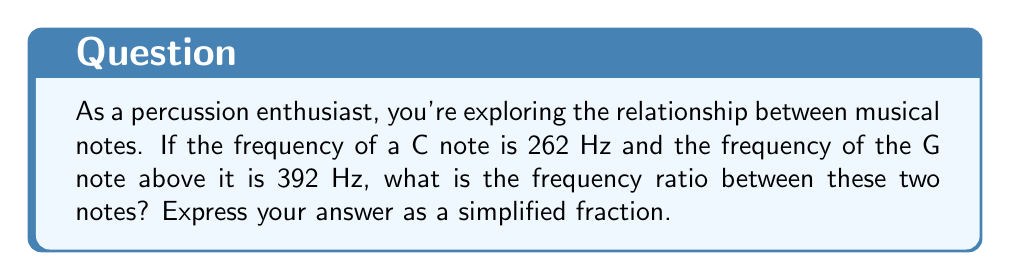Can you solve this math problem? Let's approach this step-by-step:

1) The frequency ratio is calculated by dividing the higher frequency by the lower frequency.

2) In this case, we have:
   G frequency = 392 Hz
   C frequency = 262 Hz

3) The ratio is:
   $$\frac{\text{G frequency}}{\text{C frequency}} = \frac{392}{262}$$

4) To simplify this fraction, we need to find the greatest common divisor (GCD) of 392 and 262.
   
5) Using the Euclidean algorithm:
   392 = 1 × 262 + 130
   262 = 2 × 130 + 2
   130 = 65 × 2 + 0
   
   The GCD is 2.

6) Dividing both the numerator and denominator by 2:
   $$\frac{392 ÷ 2}{262 ÷ 2} = \frac{196}{131}$$

This simplified fraction, 196/131, represents the frequency ratio between the G and C notes.
Answer: $\frac{196}{131}$ 